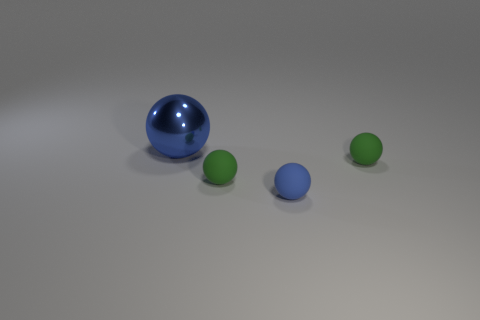Subtract all small spheres. How many spheres are left? 1 Add 2 big blue objects. How many objects exist? 6 Subtract all blue blocks. How many green balls are left? 2 Subtract all blue spheres. How many spheres are left? 2 Subtract 0 purple cubes. How many objects are left? 4 Subtract 2 spheres. How many spheres are left? 2 Subtract all gray balls. Subtract all red cylinders. How many balls are left? 4 Subtract all large purple metal objects. Subtract all metallic balls. How many objects are left? 3 Add 2 big blue shiny spheres. How many big blue shiny spheres are left? 3 Add 4 green matte spheres. How many green matte spheres exist? 6 